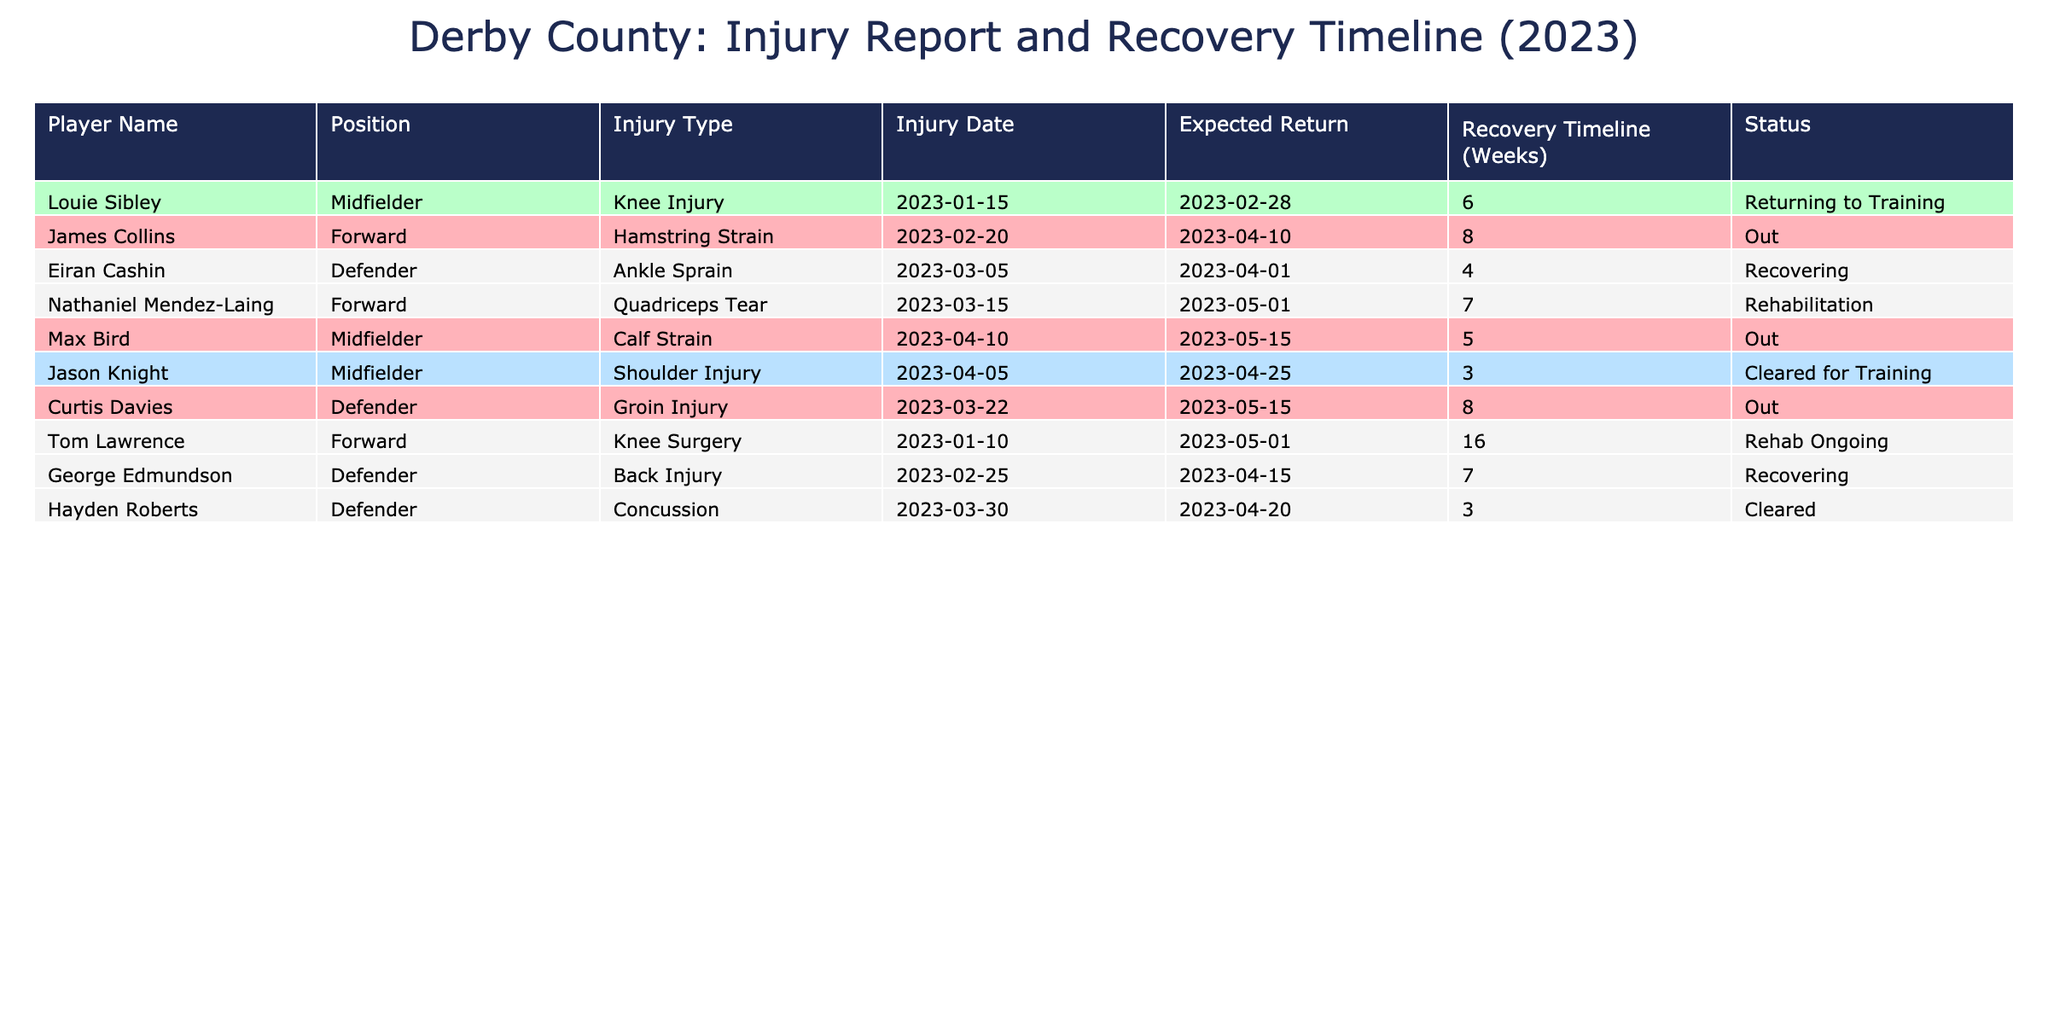What is the injury type for Jason Knight? The table lists Jason Knight under "Player Name" and states his injury type is "Shoulder Injury."
Answer: Shoulder Injury How many weeks is Louie Sibley expected to be in recovery? The table shows Louie Sibley has a recovery timeline of 6 weeks.
Answer: 6 weeks Who is the player with the longest expected recovery time? By examining the expected return dates, Tom Lawrence has the longest recovery timeline of 16 weeks due to knee surgery.
Answer: Tom Lawrence How many players are currently out due to their injuries? The table indicates that James Collins, Max Bird, and Curtis Davies are listed as "Out," giving a total of 3 players.
Answer: 3 players What is the status of Nathaniel Mendez-Laing? The table indicates that Nathaniel Mendez-Laing is in "Rehabilitation," which means he is working towards recovery.
Answer: Rehabilitation How many players have a recovery timeline of 3 weeks or less? The table includes Jason Knight and Hayden Roberts, both with recovery timelines of 3 weeks, totaling 2 players.
Answer: 2 players Is Eiran Cashin expected to return before or after George Edmundson? Eiran Cashin is expected to return on 2023-04-01, while George Edmundson is expected to return on 2023-04-15. Since April 1 is before April 15, Eiran Cashin will return first.
Answer: Before What is the average recovery timeline of all players? Adding the recovery timelines (6 + 8 + 4 + 7 + 5 + 3 + 8 + 16 + 7 + 3) gives a total of 63 weeks. There are 10 players, so the average is 63/10 = 6.3 weeks.
Answer: 6.3 weeks Which position has the highest number of players listed as out? The Forward position has 2 players (James Collins and Nathaniel Mendez-Laing) listed as out, compared to other positions.
Answer: Forward Is there any player cleared for training? Yes, both Jason Knight and Hayden Roberts are marked as "Cleared for Training" in the table.
Answer: Yes, 2 players 